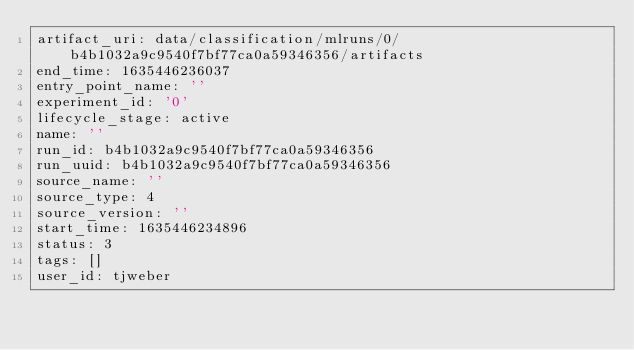Convert code to text. <code><loc_0><loc_0><loc_500><loc_500><_YAML_>artifact_uri: data/classification/mlruns/0/b4b1032a9c9540f7bf77ca0a59346356/artifacts
end_time: 1635446236037
entry_point_name: ''
experiment_id: '0'
lifecycle_stage: active
name: ''
run_id: b4b1032a9c9540f7bf77ca0a59346356
run_uuid: b4b1032a9c9540f7bf77ca0a59346356
source_name: ''
source_type: 4
source_version: ''
start_time: 1635446234896
status: 3
tags: []
user_id: tjweber
</code> 